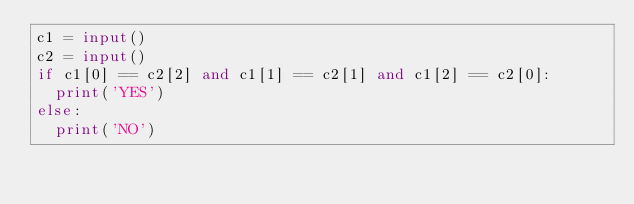Convert code to text. <code><loc_0><loc_0><loc_500><loc_500><_Python_>c1 = input()
c2 = input()
if c1[0] == c2[2] and c1[1] == c2[1] and c1[2] == c2[0]:
  print('YES')
else:
  print('NO')</code> 